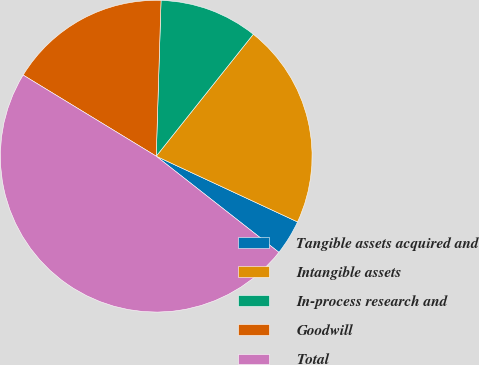Convert chart to OTSL. <chart><loc_0><loc_0><loc_500><loc_500><pie_chart><fcel>Tangible assets acquired and<fcel>Intangible assets<fcel>In-process research and<fcel>Goodwill<fcel>Total<nl><fcel>3.65%<fcel>21.23%<fcel>10.21%<fcel>16.78%<fcel>48.14%<nl></chart> 